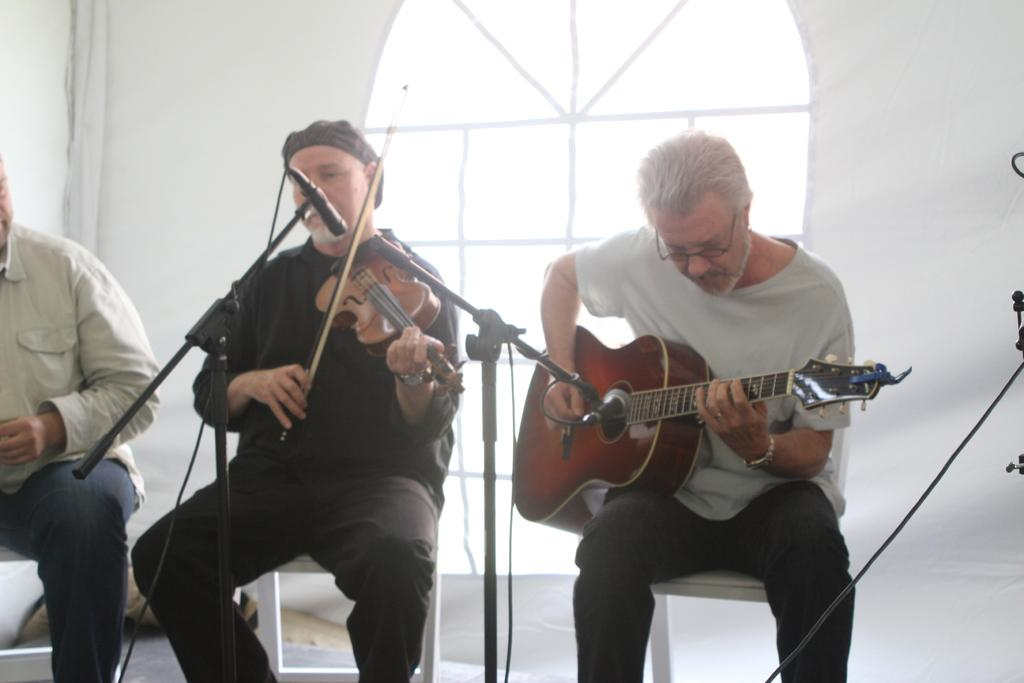What is the person in the image wearing? The person in the image is wearing a T-shirt. What activity is the person in the T-shirt engaged in? The person in the T-shirt is playing a guitar. What object is in front of the person playing the guitar? There is a microphone in front of the person playing the guitar. Who else is playing an instrument in the image? There is a person playing a violin in the image. Where is the person playing the violin located in relation to the person playing the guitar? The person playing the violin is standing beside the person playing the guitar. What object is in front of the person playing the violin? There is a microphone in front of the person playing the violin. Can you describe the person sitting in the left corner of the image? There is a person sitting in the left corner of the image, but no specific details about their appearance or activity are provided. What type of tree is growing in the middle of the image? There is no tree present in the image; it features two people playing musical instruments and a person sitting in the corner. What statement does the person sitting in the corner make in the image? There is no indication in the image that the person sitting in the corner is making a statement or speaking. 